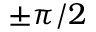Convert formula to latex. <formula><loc_0><loc_0><loc_500><loc_500>\pm \pi / 2</formula> 